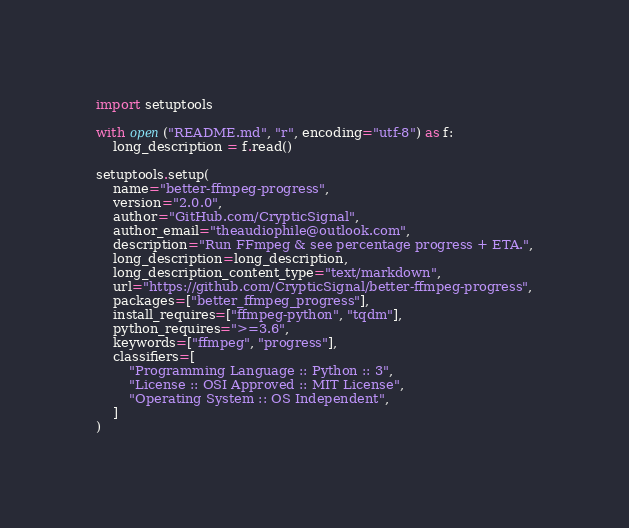Convert code to text. <code><loc_0><loc_0><loc_500><loc_500><_Python_>import setuptools

with open("README.md", "r", encoding="utf-8") as f:
    long_description = f.read()

setuptools.setup(
    name="better-ffmpeg-progress",
    version="2.0.0",
    author="GitHub.com/CrypticSignal",
    author_email="theaudiophile@outlook.com",
    description="Run FFmpeg & see percentage progress + ETA.",
    long_description=long_description,
    long_description_content_type="text/markdown",
    url="https://github.com/CrypticSignal/better-ffmpeg-progress",
    packages=["better_ffmpeg_progress"],
    install_requires=["ffmpeg-python", "tqdm"],
    python_requires=">=3.6",
    keywords=["ffmpeg", "progress"],
    classifiers=[
        "Programming Language :: Python :: 3",
        "License :: OSI Approved :: MIT License",
        "Operating System :: OS Independent",
    ]
)</code> 